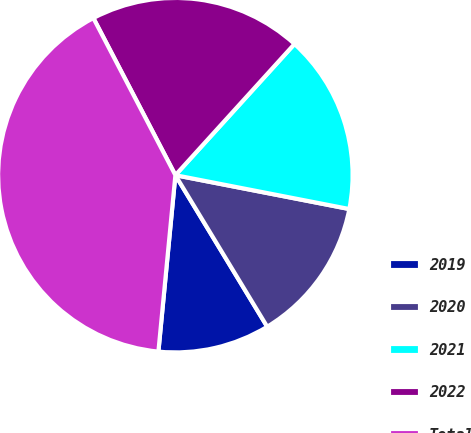<chart> <loc_0><loc_0><loc_500><loc_500><pie_chart><fcel>2019<fcel>2020<fcel>2021<fcel>2022<fcel>Total<nl><fcel>10.2%<fcel>13.27%<fcel>16.33%<fcel>19.39%<fcel>40.82%<nl></chart> 